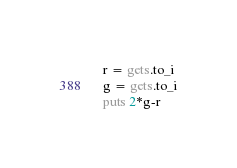Convert code to text. <code><loc_0><loc_0><loc_500><loc_500><_Ruby_>r = gets.to_i
g = gets.to_i
puts 2*g-r
</code> 